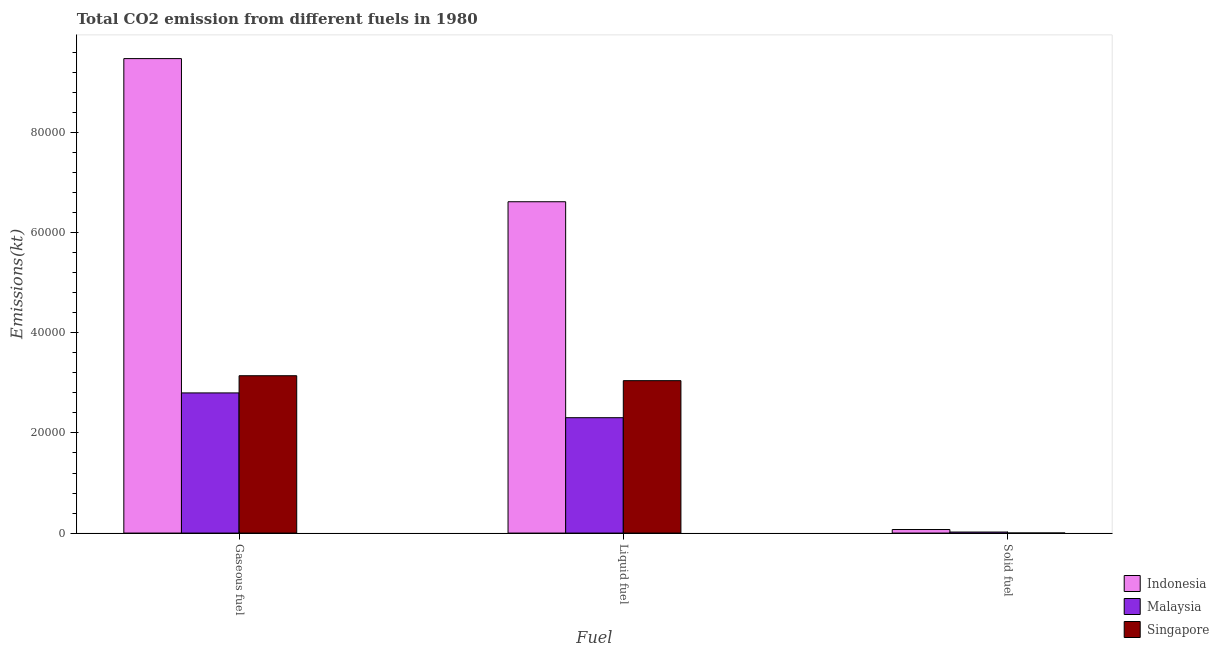How many groups of bars are there?
Make the answer very short. 3. Are the number of bars on each tick of the X-axis equal?
Provide a short and direct response. Yes. How many bars are there on the 1st tick from the right?
Give a very brief answer. 3. What is the label of the 3rd group of bars from the left?
Provide a short and direct response. Solid fuel. What is the amount of co2 emissions from liquid fuel in Malaysia?
Your answer should be very brief. 2.30e+04. Across all countries, what is the maximum amount of co2 emissions from solid fuel?
Your answer should be very brief. 707.73. Across all countries, what is the minimum amount of co2 emissions from liquid fuel?
Your answer should be very brief. 2.30e+04. In which country was the amount of co2 emissions from solid fuel minimum?
Your answer should be compact. Singapore. What is the total amount of co2 emissions from gaseous fuel in the graph?
Keep it short and to the point. 1.54e+05. What is the difference between the amount of co2 emissions from gaseous fuel in Malaysia and that in Indonesia?
Your response must be concise. -6.68e+04. What is the difference between the amount of co2 emissions from solid fuel in Indonesia and the amount of co2 emissions from gaseous fuel in Malaysia?
Your answer should be very brief. -2.73e+04. What is the average amount of co2 emissions from liquid fuel per country?
Offer a terse response. 3.99e+04. What is the difference between the amount of co2 emissions from liquid fuel and amount of co2 emissions from solid fuel in Malaysia?
Make the answer very short. 2.28e+04. What is the ratio of the amount of co2 emissions from gaseous fuel in Indonesia to that in Singapore?
Your response must be concise. 3.02. What is the difference between the highest and the second highest amount of co2 emissions from gaseous fuel?
Offer a very short reply. 6.34e+04. What is the difference between the highest and the lowest amount of co2 emissions from solid fuel?
Offer a very short reply. 696.73. In how many countries, is the amount of co2 emissions from gaseous fuel greater than the average amount of co2 emissions from gaseous fuel taken over all countries?
Offer a terse response. 1. Is the sum of the amount of co2 emissions from solid fuel in Singapore and Indonesia greater than the maximum amount of co2 emissions from liquid fuel across all countries?
Offer a very short reply. No. What does the 3rd bar from the left in Gaseous fuel represents?
Provide a short and direct response. Singapore. What does the 2nd bar from the right in Solid fuel represents?
Your answer should be compact. Malaysia. Is it the case that in every country, the sum of the amount of co2 emissions from gaseous fuel and amount of co2 emissions from liquid fuel is greater than the amount of co2 emissions from solid fuel?
Ensure brevity in your answer.  Yes. What is the difference between two consecutive major ticks on the Y-axis?
Your response must be concise. 2.00e+04. Are the values on the major ticks of Y-axis written in scientific E-notation?
Offer a very short reply. No. How are the legend labels stacked?
Your response must be concise. Vertical. What is the title of the graph?
Offer a terse response. Total CO2 emission from different fuels in 1980. What is the label or title of the X-axis?
Keep it short and to the point. Fuel. What is the label or title of the Y-axis?
Your answer should be very brief. Emissions(kt). What is the Emissions(kt) of Indonesia in Gaseous fuel?
Your response must be concise. 9.48e+04. What is the Emissions(kt) in Malaysia in Gaseous fuel?
Your response must be concise. 2.80e+04. What is the Emissions(kt) in Singapore in Gaseous fuel?
Offer a very short reply. 3.14e+04. What is the Emissions(kt) of Indonesia in Liquid fuel?
Ensure brevity in your answer.  6.62e+04. What is the Emissions(kt) of Malaysia in Liquid fuel?
Your answer should be very brief. 2.30e+04. What is the Emissions(kt) in Singapore in Liquid fuel?
Provide a short and direct response. 3.04e+04. What is the Emissions(kt) in Indonesia in Solid fuel?
Your answer should be compact. 707.73. What is the Emissions(kt) in Malaysia in Solid fuel?
Offer a very short reply. 205.35. What is the Emissions(kt) of Singapore in Solid fuel?
Your response must be concise. 11. Across all Fuel, what is the maximum Emissions(kt) of Indonesia?
Offer a terse response. 9.48e+04. Across all Fuel, what is the maximum Emissions(kt) of Malaysia?
Offer a terse response. 2.80e+04. Across all Fuel, what is the maximum Emissions(kt) in Singapore?
Give a very brief answer. 3.14e+04. Across all Fuel, what is the minimum Emissions(kt) of Indonesia?
Provide a short and direct response. 707.73. Across all Fuel, what is the minimum Emissions(kt) of Malaysia?
Your response must be concise. 205.35. Across all Fuel, what is the minimum Emissions(kt) of Singapore?
Keep it short and to the point. 11. What is the total Emissions(kt) of Indonesia in the graph?
Your answer should be very brief. 1.62e+05. What is the total Emissions(kt) in Malaysia in the graph?
Your response must be concise. 5.12e+04. What is the total Emissions(kt) in Singapore in the graph?
Ensure brevity in your answer.  6.19e+04. What is the difference between the Emissions(kt) in Indonesia in Gaseous fuel and that in Liquid fuel?
Your answer should be compact. 2.86e+04. What is the difference between the Emissions(kt) in Malaysia in Gaseous fuel and that in Liquid fuel?
Give a very brief answer. 4950.45. What is the difference between the Emissions(kt) of Singapore in Gaseous fuel and that in Liquid fuel?
Offer a very short reply. 986.42. What is the difference between the Emissions(kt) of Indonesia in Gaseous fuel and that in Solid fuel?
Your answer should be compact. 9.41e+04. What is the difference between the Emissions(kt) of Malaysia in Gaseous fuel and that in Solid fuel?
Your response must be concise. 2.78e+04. What is the difference between the Emissions(kt) of Singapore in Gaseous fuel and that in Solid fuel?
Give a very brief answer. 3.14e+04. What is the difference between the Emissions(kt) of Indonesia in Liquid fuel and that in Solid fuel?
Offer a very short reply. 6.55e+04. What is the difference between the Emissions(kt) of Malaysia in Liquid fuel and that in Solid fuel?
Keep it short and to the point. 2.28e+04. What is the difference between the Emissions(kt) of Singapore in Liquid fuel and that in Solid fuel?
Your answer should be compact. 3.04e+04. What is the difference between the Emissions(kt) in Indonesia in Gaseous fuel and the Emissions(kt) in Malaysia in Liquid fuel?
Make the answer very short. 7.17e+04. What is the difference between the Emissions(kt) of Indonesia in Gaseous fuel and the Emissions(kt) of Singapore in Liquid fuel?
Keep it short and to the point. 6.43e+04. What is the difference between the Emissions(kt) in Malaysia in Gaseous fuel and the Emissions(kt) in Singapore in Liquid fuel?
Ensure brevity in your answer.  -2449.56. What is the difference between the Emissions(kt) in Indonesia in Gaseous fuel and the Emissions(kt) in Malaysia in Solid fuel?
Provide a short and direct response. 9.46e+04. What is the difference between the Emissions(kt) in Indonesia in Gaseous fuel and the Emissions(kt) in Singapore in Solid fuel?
Make the answer very short. 9.48e+04. What is the difference between the Emissions(kt) in Malaysia in Gaseous fuel and the Emissions(kt) in Singapore in Solid fuel?
Keep it short and to the point. 2.80e+04. What is the difference between the Emissions(kt) of Indonesia in Liquid fuel and the Emissions(kt) of Malaysia in Solid fuel?
Offer a terse response. 6.60e+04. What is the difference between the Emissions(kt) of Indonesia in Liquid fuel and the Emissions(kt) of Singapore in Solid fuel?
Offer a very short reply. 6.62e+04. What is the difference between the Emissions(kt) in Malaysia in Liquid fuel and the Emissions(kt) in Singapore in Solid fuel?
Give a very brief answer. 2.30e+04. What is the average Emissions(kt) of Indonesia per Fuel?
Your answer should be very brief. 5.39e+04. What is the average Emissions(kt) of Malaysia per Fuel?
Make the answer very short. 1.71e+04. What is the average Emissions(kt) of Singapore per Fuel?
Give a very brief answer. 2.06e+04. What is the difference between the Emissions(kt) of Indonesia and Emissions(kt) of Malaysia in Gaseous fuel?
Offer a terse response. 6.68e+04. What is the difference between the Emissions(kt) in Indonesia and Emissions(kt) in Singapore in Gaseous fuel?
Offer a very short reply. 6.34e+04. What is the difference between the Emissions(kt) in Malaysia and Emissions(kt) in Singapore in Gaseous fuel?
Your response must be concise. -3435.98. What is the difference between the Emissions(kt) of Indonesia and Emissions(kt) of Malaysia in Liquid fuel?
Provide a short and direct response. 4.31e+04. What is the difference between the Emissions(kt) of Indonesia and Emissions(kt) of Singapore in Liquid fuel?
Make the answer very short. 3.57e+04. What is the difference between the Emissions(kt) in Malaysia and Emissions(kt) in Singapore in Liquid fuel?
Your answer should be compact. -7400.01. What is the difference between the Emissions(kt) in Indonesia and Emissions(kt) in Malaysia in Solid fuel?
Your answer should be very brief. 502.38. What is the difference between the Emissions(kt) of Indonesia and Emissions(kt) of Singapore in Solid fuel?
Offer a very short reply. 696.73. What is the difference between the Emissions(kt) in Malaysia and Emissions(kt) in Singapore in Solid fuel?
Keep it short and to the point. 194.35. What is the ratio of the Emissions(kt) in Indonesia in Gaseous fuel to that in Liquid fuel?
Your response must be concise. 1.43. What is the ratio of the Emissions(kt) in Malaysia in Gaseous fuel to that in Liquid fuel?
Ensure brevity in your answer.  1.21. What is the ratio of the Emissions(kt) of Singapore in Gaseous fuel to that in Liquid fuel?
Offer a terse response. 1.03. What is the ratio of the Emissions(kt) of Indonesia in Gaseous fuel to that in Solid fuel?
Make the answer very short. 133.93. What is the ratio of the Emissions(kt) of Malaysia in Gaseous fuel to that in Solid fuel?
Provide a short and direct response. 136.34. What is the ratio of the Emissions(kt) of Singapore in Gaseous fuel to that in Solid fuel?
Give a very brief answer. 2857.33. What is the ratio of the Emissions(kt) in Indonesia in Liquid fuel to that in Solid fuel?
Provide a short and direct response. 93.52. What is the ratio of the Emissions(kt) in Malaysia in Liquid fuel to that in Solid fuel?
Provide a succinct answer. 112.23. What is the ratio of the Emissions(kt) in Singapore in Liquid fuel to that in Solid fuel?
Offer a very short reply. 2767.67. What is the difference between the highest and the second highest Emissions(kt) in Indonesia?
Your answer should be very brief. 2.86e+04. What is the difference between the highest and the second highest Emissions(kt) in Malaysia?
Your response must be concise. 4950.45. What is the difference between the highest and the second highest Emissions(kt) in Singapore?
Offer a terse response. 986.42. What is the difference between the highest and the lowest Emissions(kt) in Indonesia?
Provide a short and direct response. 9.41e+04. What is the difference between the highest and the lowest Emissions(kt) of Malaysia?
Provide a succinct answer. 2.78e+04. What is the difference between the highest and the lowest Emissions(kt) in Singapore?
Offer a terse response. 3.14e+04. 